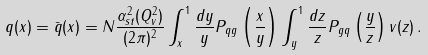Convert formula to latex. <formula><loc_0><loc_0><loc_500><loc_500>q ( x ) = \bar { q } ( x ) = N \frac { \alpha _ { s t } ^ { 2 } ( Q ^ { 2 } _ { v } ) } { ( 2 \pi ) ^ { 2 } } \int _ { x } ^ { 1 } { \frac { d y } { y } P _ { q g } \left ( \frac { x } { y } \right ) \int _ { y } ^ { 1 } { \frac { d z } { z } P _ { g q } \left ( \frac { y } { z } \right ) v ( z ) } } \, .</formula> 